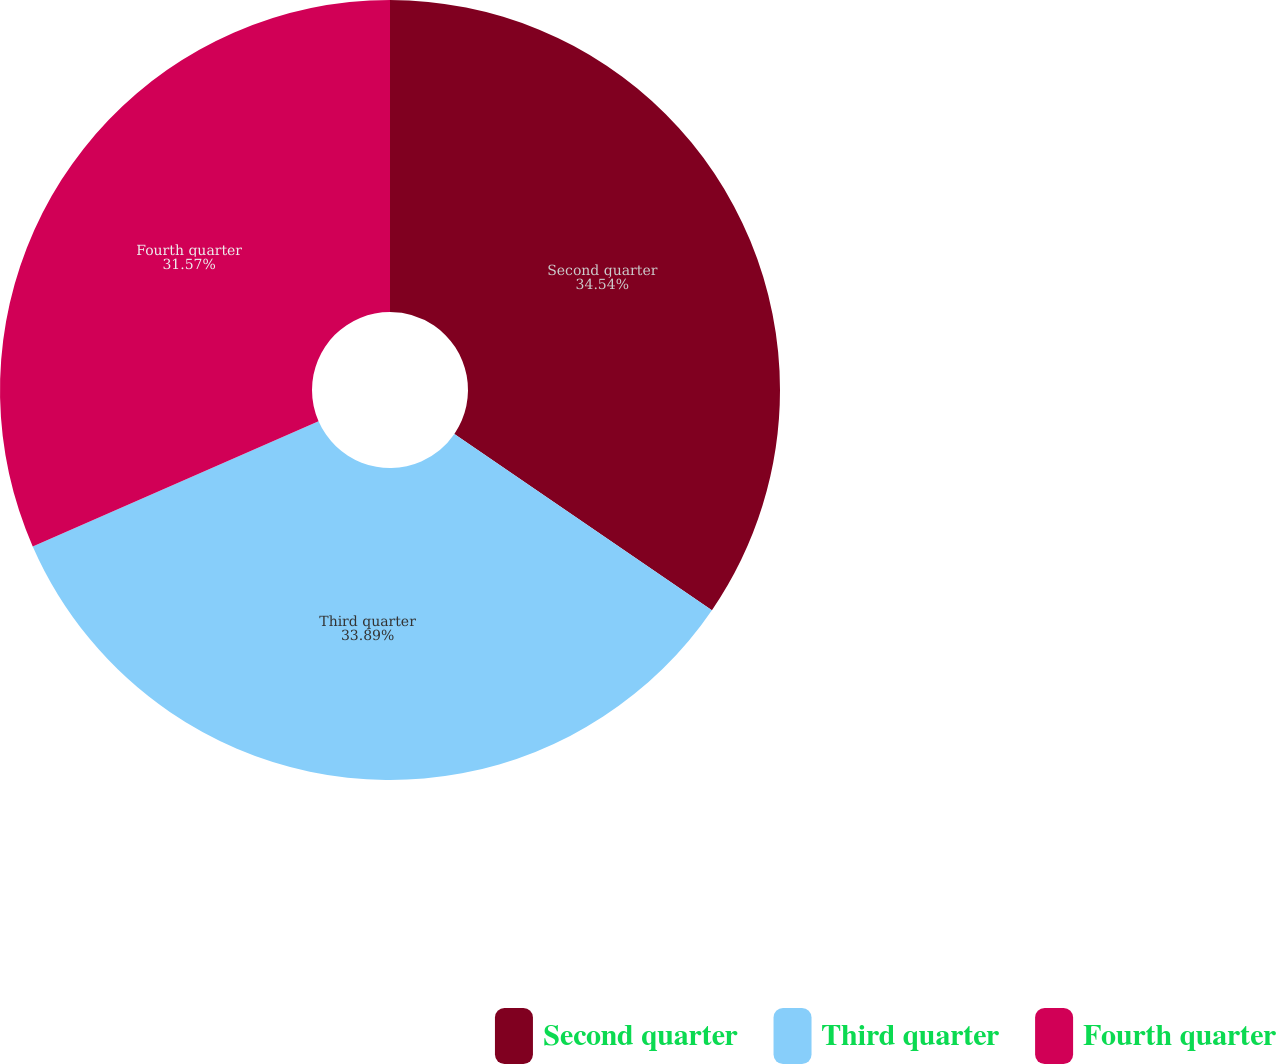<chart> <loc_0><loc_0><loc_500><loc_500><pie_chart><fcel>Second quarter<fcel>Third quarter<fcel>Fourth quarter<nl><fcel>34.55%<fcel>33.89%<fcel>31.57%<nl></chart> 